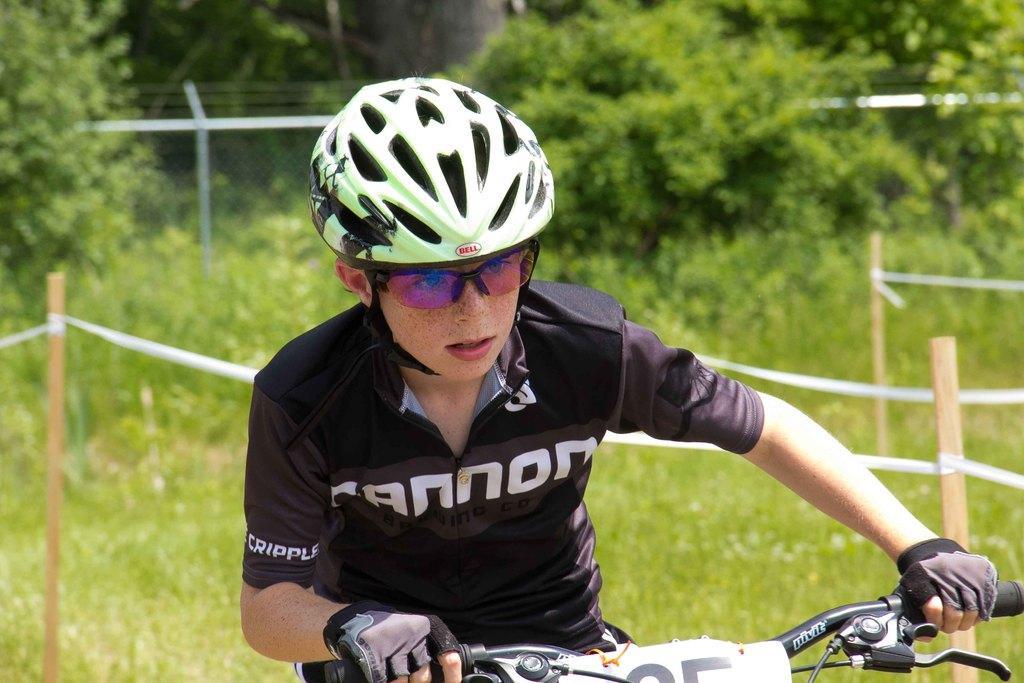In one or two sentences, can you explain what this image depicts? This picture is clicked outside. In the foreground we can see a person wearing a t-shirt, helmet, gloves and riding a bicycle. In the background we can see the wooden poles, ropes, green grass, plants and trees and some other objects. 